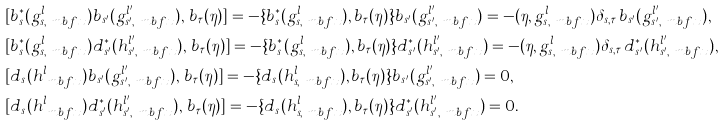Convert formula to latex. <formula><loc_0><loc_0><loc_500><loc_500>& [ b _ { s } ^ { \ast } ( g _ { s , \ m b f { x } } ^ { l } ) b _ { s ^ { \prime } } ( g _ { s ^ { \prime } , \ m b f { x } } ^ { l ^ { \prime } } ) , \, b _ { \tau } ( \eta ) ] = - \{ b _ { s } ^ { \ast } ( g _ { s , \ m b f { x } } ^ { l } ) , b _ { \tau } ( \eta ) \} b _ { s ^ { \prime } } ( g _ { s ^ { \prime } , \ m b f { x } } ^ { l ^ { \prime } } ) = - ( \eta , g _ { s , \ m b f { x } } ^ { l } ) \delta _ { s , \tau } \, b _ { s ^ { \prime } } ( g _ { s ^ { \prime } , \ m b f { x } } ^ { l ^ { \prime } } ) , \\ & [ b _ { s } ^ { \ast } ( g _ { s , \ m b f { x } } ^ { l } ) d ^ { \ast } _ { s ^ { \prime } } ( h _ { s ^ { \prime } , \ m b f { x } } ^ { l ^ { \prime } } ) , \, b _ { \tau } ( \eta ) ] = - \{ b _ { s } ^ { \ast } ( g _ { s , \ m b f { x } } ^ { l } ) , b _ { \tau } ( \eta ) \} d ^ { \ast } _ { s ^ { \prime } } ( h _ { s ^ { \prime } , \ m b f { x } } ^ { l ^ { \prime } } ) = - ( \eta , g _ { s , \ m b f { x } } ^ { l } ) \delta _ { s , \tau } \, d ^ { \ast } _ { s ^ { \prime } } ( h _ { s ^ { \prime } , \ m b f { x } } ^ { l ^ { \prime } } ) , \\ & [ d _ { s } ( h _ { \ m b f { x } } ^ { l } ) b _ { s ^ { \prime } } ( g _ { s ^ { \prime } , \ m b f { x } } ^ { l ^ { \prime } } ) , \, b _ { \tau } ( \eta ) ] = - \{ d _ { s } ( h _ { s , \ m b f { x } } ^ { l } ) , b _ { \tau } ( \eta ) \} b _ { s ^ { \prime } } ( g _ { s ^ { \prime } , \ m b f { x } } ^ { l ^ { \prime } } ) = 0 , \\ & [ d _ { s } ( h _ { \ m b f { x } } ^ { l } ) d ^ { \ast } _ { s ^ { \prime } } ( h _ { s ^ { \prime } , \ m b f { x } } ^ { l ^ { \prime } } ) , \, b _ { \tau } ( \eta ) ] = - \{ d _ { s } ( h _ { s , \ m b f { x } } ^ { l } ) , b _ { \tau } ( \eta ) \} d ^ { \ast } _ { s ^ { \prime } } ( h _ { s ^ { \prime } , \ m b f { x } } ^ { l ^ { \prime } } ) = 0 .</formula> 